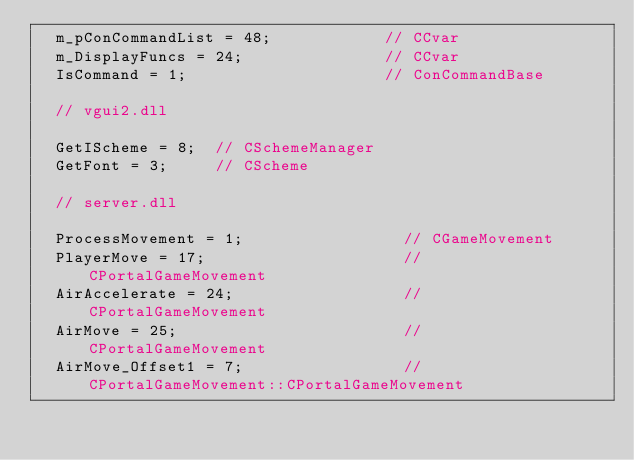<code> <loc_0><loc_0><loc_500><loc_500><_C++_>	m_pConCommandList = 48;            // CCvar
	m_DisplayFuncs = 24;               // CCvar
	IsCommand = 1;                     // ConCommandBase

	// vgui2.dll

	GetIScheme = 8;  // CSchemeManager
	GetFont = 3;     // CScheme

	// server.dll

	ProcessMovement = 1;                 // CGameMovement
	PlayerMove = 17;                     // CPortalGameMovement
	AirAccelerate = 24;                  // CPortalGameMovement
	AirMove = 25;                        // CPortalGameMovement
	AirMove_Offset1 = 7;                 // CPortalGameMovement::CPortalGameMovement</code> 